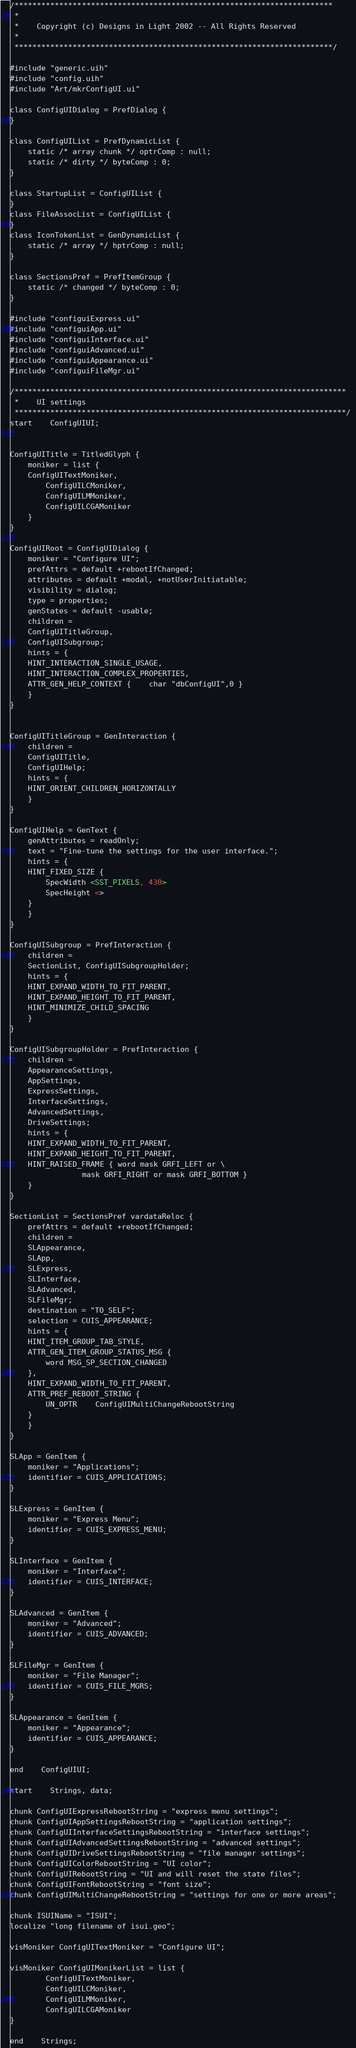Convert code to text. <code><loc_0><loc_0><loc_500><loc_500><_XML_>/***********************************************************************
 *
 *	Copyright (c) Designs in Light 2002 -- All Rights Reserved
 *
 ***********************************************************************/

#include "generic.uih"
#include "config.uih"
#include "Art/mkrConfigUI.ui"

class ConfigUIDialog = PrefDialog {
}

class ConfigUIList = PrefDynamicList {
    static /* array chunk */ optrComp : null;
    static /* dirty */ byteComp : 0;
}

class StartupList = ConfigUIList {
}
class FileAssocList = ConfigUIList {
}
class IconTokenList = GenDynamicList {
    static /* array */ hptrComp : null;
}

class SectionsPref = PrefItemGroup {
    static /* changed */ byteComp : 0;
}

#include "configuiExpress.ui"
#include "configuiApp.ui"
#include "configuiInterface.ui"
#include "configuiAdvanced.ui"
#include "configuiAppearance.ui"
#include "configuiFileMgr.ui"

/**************************************************************************
 *	UI settings
 **************************************************************************/ 
start	ConfigUIUI;


ConfigUITitle = TitledGlyph {
    moniker = list {
	ConfigUITextMoniker,
	    ConfigUILCMoniker,
	    ConfigUILMMoniker,
	    ConfigUILCGAMoniker
    }
}

ConfigUIRoot = ConfigUIDialog {
    moniker = "Configure UI";
    prefAttrs = default +rebootIfChanged;
    attributes = default +modal, +notUserInitiatable;
    visibility = dialog;
    type = properties;
    genStates = default -usable;
    children =
	ConfigUITitleGroup,
	ConfigUISubgroup;
    hints = {
	HINT_INTERACTION_SINGLE_USAGE,
	HINT_INTERACTION_COMPLEX_PROPERTIES,
	ATTR_GEN_HELP_CONTEXT {	char "dbConfigUI",0 } 
    }
}


ConfigUITitleGroup = GenInteraction {
    children =
	ConfigUITitle,
	ConfigUIHelp;
    hints = {
	HINT_ORIENT_CHILDREN_HORIZONTALLY
    }
}

ConfigUIHelp = GenText {
    genAttributes = readOnly;
    text = "Fine-tune the settings for the user interface.";
    hints = {
	HINT_FIXED_SIZE {
	    SpecWidth <SST_PIXELS, 430>
	    SpecHeight <>
	}
    }
}

ConfigUISubgroup = PrefInteraction {
    children =
	SectionList, ConfigUISubgroupHolder;
    hints = {
	HINT_EXPAND_WIDTH_TO_FIT_PARENT,
	HINT_EXPAND_HEIGHT_TO_FIT_PARENT,
	HINT_MINIMIZE_CHILD_SPACING
    }
}

ConfigUISubgroupHolder = PrefInteraction {
    children =
	AppearanceSettings,
	AppSettings,
	ExpressSettings,
	InterfaceSettings,
	AdvancedSettings,
	DriveSettings;
    hints = {
	HINT_EXPAND_WIDTH_TO_FIT_PARENT,
	HINT_EXPAND_HEIGHT_TO_FIT_PARENT,
	HINT_RAISED_FRAME { word mask GRFI_LEFT or \
			    mask GRFI_RIGHT or mask GRFI_BOTTOM }
    }
}

SectionList = SectionsPref vardataReloc {
    prefAttrs = default +rebootIfChanged;
    children =
	SLAppearance,
	SLApp,
	SLExpress,
	SLInterface,
	SLAdvanced,
	SLFileMgr;
    destination = "TO_SELF";
    selection = CUIS_APPEARANCE;
    hints = {
	HINT_ITEM_GROUP_TAB_STYLE,
	ATTR_GEN_ITEM_GROUP_STATUS_MSG {
	    word MSG_SP_SECTION_CHANGED
	},
	HINT_EXPAND_WIDTH_TO_FIT_PARENT,
	ATTR_PREF_REBOOT_STRING {
	    UN_OPTR	ConfigUIMultiChangeRebootString
	}
    }
}

SLApp = GenItem {
    moniker = "Applications";
    identifier = CUIS_APPLICATIONS;
}

SLExpress = GenItem {
    moniker = "Express Menu";
    identifier = CUIS_EXPRESS_MENU;
}

SLInterface = GenItem {
    moniker = "Interface";
    identifier = CUIS_INTERFACE;
}

SLAdvanced = GenItem {
    moniker = "Advanced";
    identifier = CUIS_ADVANCED;
}

SLFileMgr = GenItem {
    moniker = "File Manager";
    identifier = CUIS_FILE_MGRS;
}

SLAppearance = GenItem {
    moniker = "Appearance";
    identifier = CUIS_APPEARANCE;
}

end	ConfigUIUI;

start	Strings, data;

chunk ConfigUIExpressRebootString = "express menu settings";
chunk ConfigUIAppSettingsRebootString = "application settings";
chunk ConfigUIInterfaceSettingsRebootString = "interface settings";
chunk ConfigUIAdvancedSettingsRebootString = "advanced settings";
chunk ConfigUIDriveSettingsRebootString = "file manager settings";
chunk ConfigUIColorRebootString = "UI color";
chunk ConfigUIRebootString = "UI and will reset the state files";
chunk ConfigUIFontRebootString = "font size";
chunk ConfigUIMultiChangeRebootString = "settings for one or more areas";

chunk ISUIName = "ISUI";
localize "long filename of isui.geo";

visMoniker ConfigUITextMoniker = "Configure UI";

visMoniker ConfigUIMonikerList = list {
		ConfigUITextMoniker,
		ConfigUILCMoniker,
		ConfigUILMMoniker,
		ConfigUILCGAMoniker
}

end	Strings;
</code> 